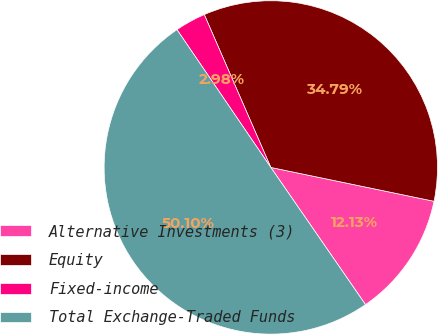Convert chart. <chart><loc_0><loc_0><loc_500><loc_500><pie_chart><fcel>Alternative Investments (3)<fcel>Equity<fcel>Fixed-income<fcel>Total Exchange-Traded Funds<nl><fcel>12.13%<fcel>34.79%<fcel>2.98%<fcel>50.1%<nl></chart> 